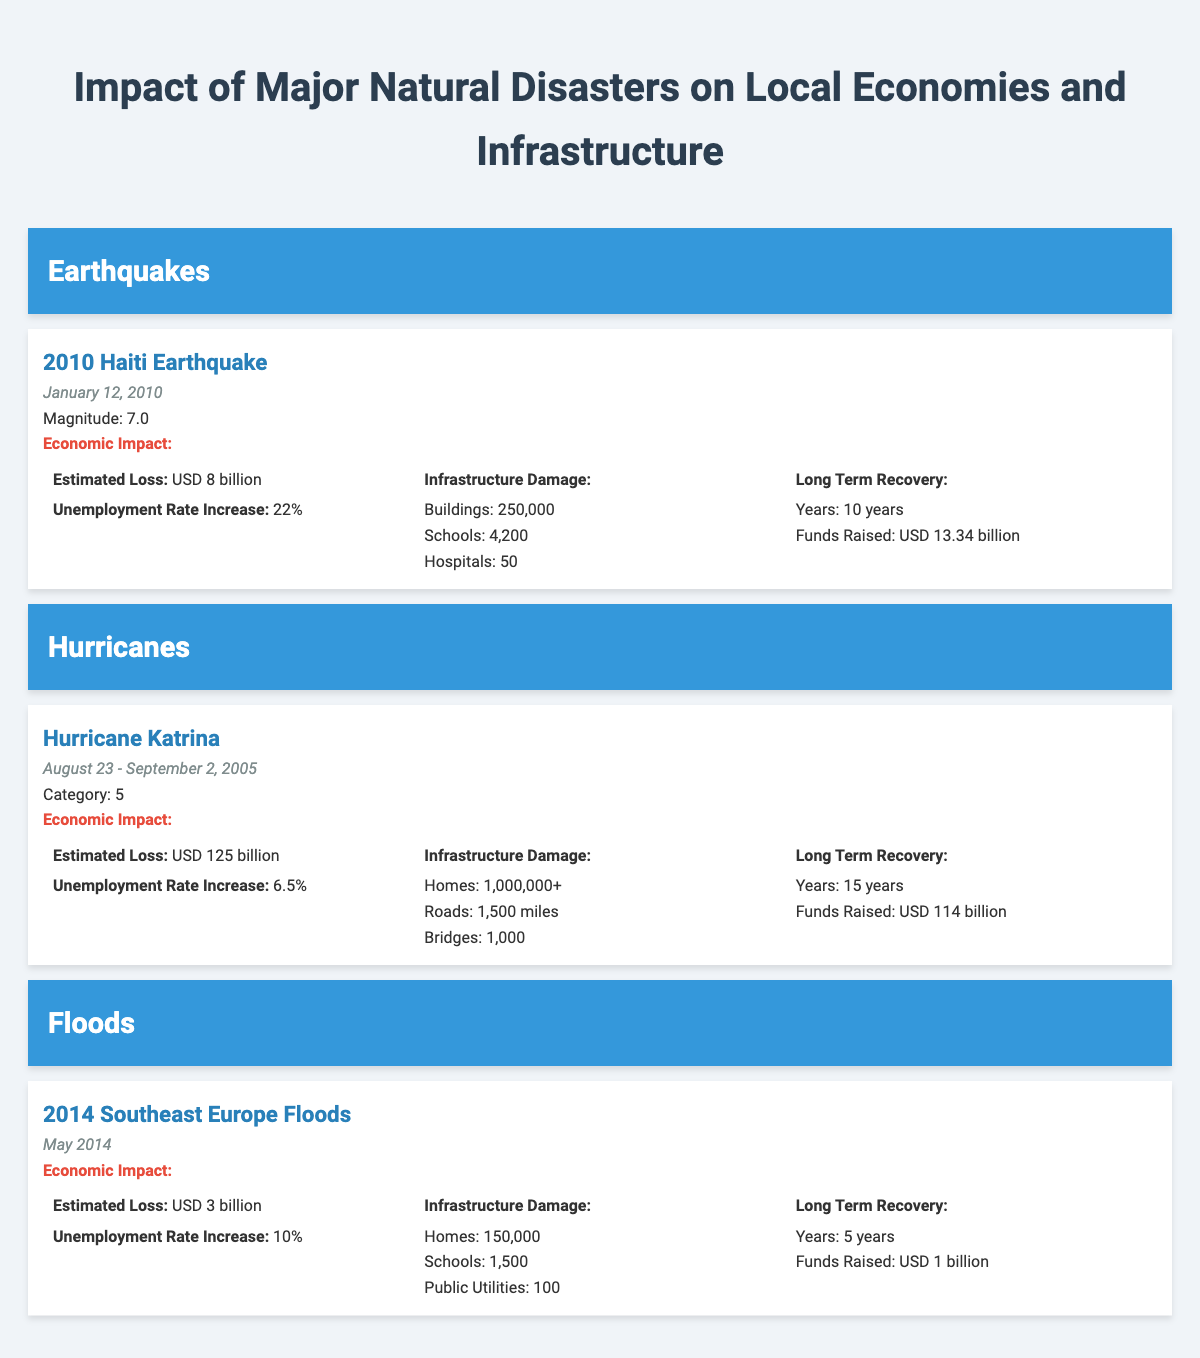What is the estimated economic loss of Hurricane Katrina? The table states that the estimated loss for Hurricane Katrina is USD 125 billion.
Answer: USD 125 billion How many schools were affected by the 2010 Haiti Earthquake? According to the table, the infrastructure damage from the 2010 Haiti Earthquake includes 4,200 schools.
Answer: 4,200 What is the total estimated loss from the 2014 Southeast Europe Floods and the 2010 Haiti Earthquake combined? The estimated loss from the 2014 Southeast Europe Floods is USD 3 billion, and from the 2010 Haiti Earthquake, it is USD 8 billion. Adding these together gives USD 3 billion + USD 8 billion = USD 11 billion.
Answer: USD 11 billion Did the 2014 Southeast Europe Floods result in a higher unemployment rate increase compared to Hurricane Katrina? The unemployment rate increase from the 2014 Southeast Europe Floods is 10%, while the increase from Hurricane Katrina is 6.5%. Therefore, the floods resulted in a higher unemployment rate increase.
Answer: Yes What was the total funds raised for long-term recovery from both Hurricane Katrina and the 2010 Haiti Earthquake? For Hurricane Katrina, funds raised are USD 114 billion, and for the 2010 Haiti Earthquake, it’s USD 13.34 billion. Summing these gives USD 114 billion + USD 13.34 billion = USD 127.34 billion.
Answer: USD 127.34 billion How many total buildings were destroyed or damaged in the 2010 Haiti Earthquake? The table indicates that 250,000 buildings were affected by the 2010 Haiti Earthquake.
Answer: 250,000 Is the unemployment rate increase greater for the 2014 Southeast Europe Floods than for the 2010 Haiti Earthquake? The unemployment rate increase for the 2014 Southeast Europe Floods is 10%, while for the 2010 Haiti Earthquake, it is 22%. Thus, the increase is not greater for the floods.
Answer: No What is the average number of homes damaged across the three natural disasters listed? The number of homes damaged is 1,000,000+ for Hurricane Katrina and 150,000 for the 2014 Southeast Europe Floods. For the 2010 Haiti Earthquake, while not specified, we can calculate an average assuming the number for homes is significantly lower. The average thus cannot be precisely determined without specific data for Haiti but can be roughly estimated as (1,000,000 + 150,000)/2 assuming a hypothetical 200,000 for Haiti. So, the average would be approximately 600,000.
Answer: Not precisely determinable, but approximately 600,000 How many hospitals were reported damaged after the 2010 Haiti Earthquake? From the table, it states that 50 hospitals were reported damaged following the earthquake.
Answer: 50 